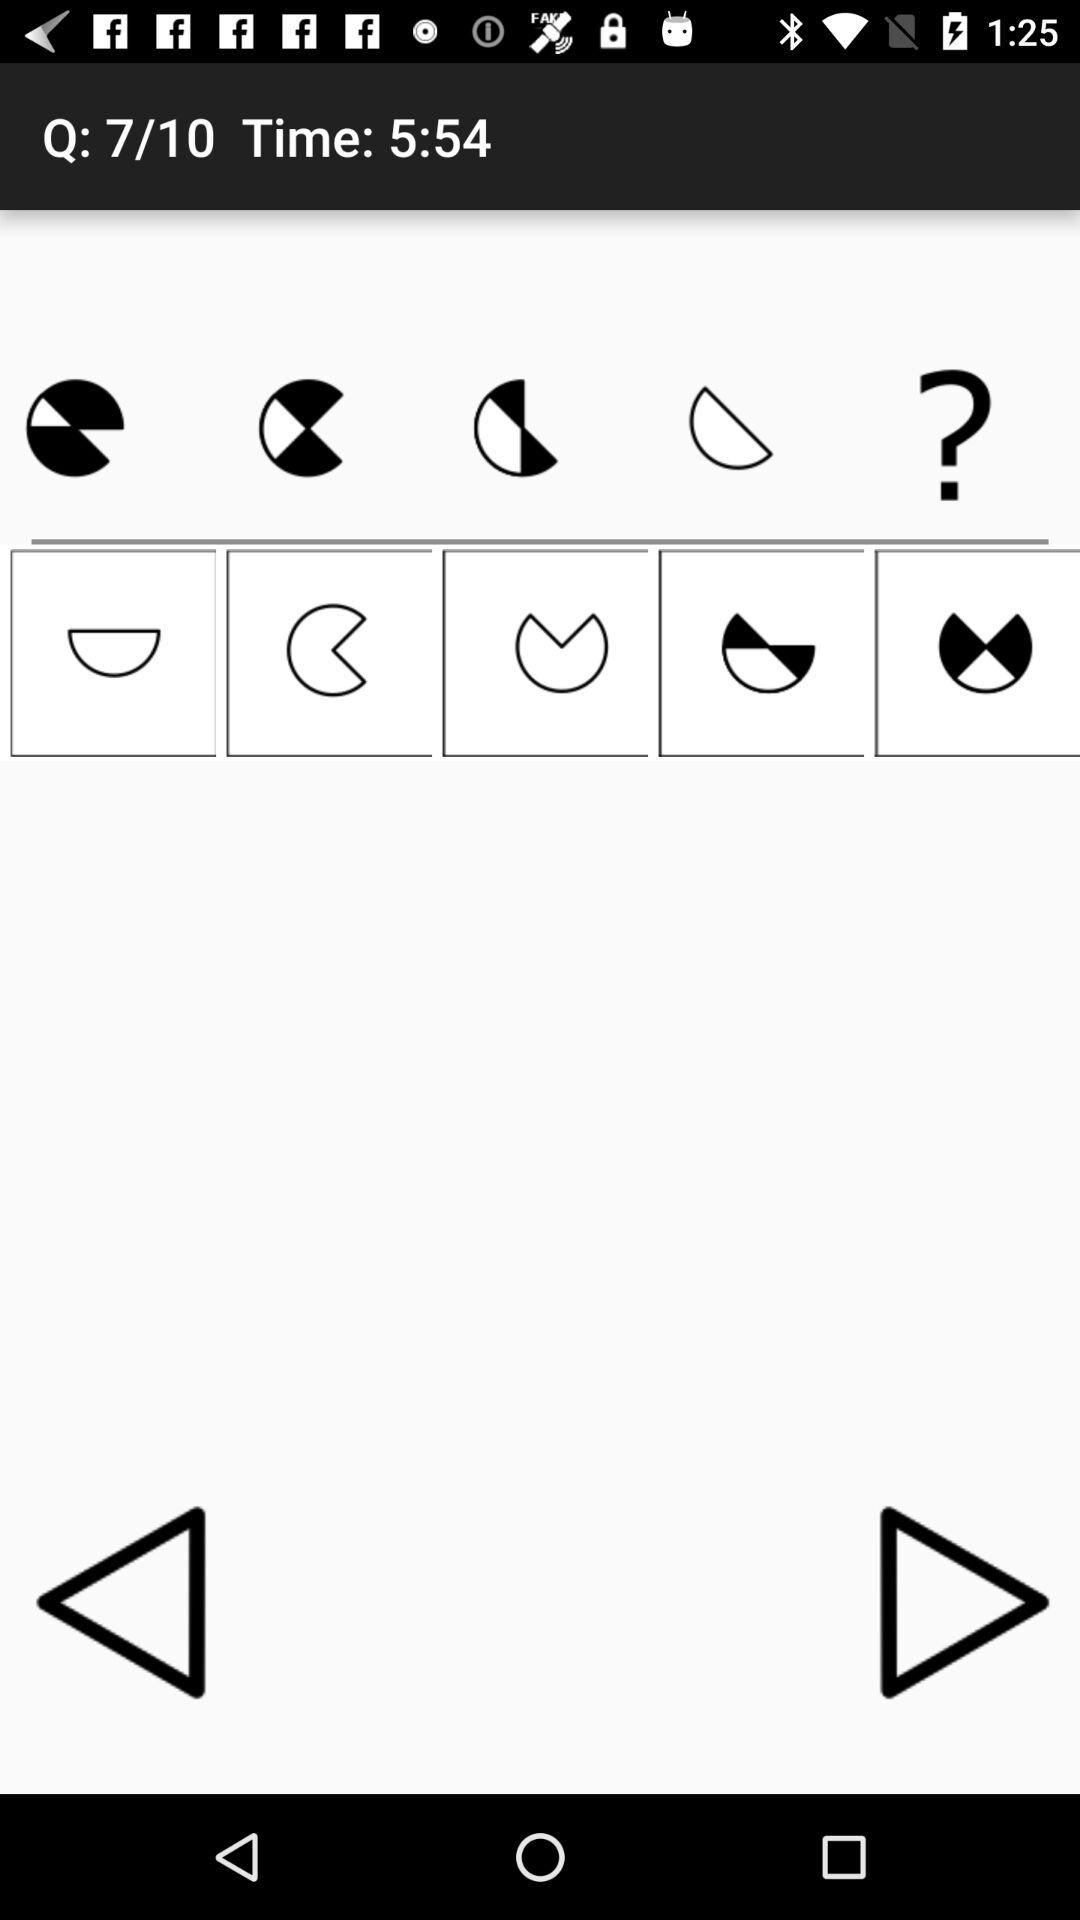Which question number am I on? You are on question number 7. 